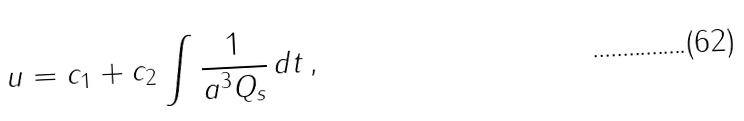<formula> <loc_0><loc_0><loc_500><loc_500>u = c _ { 1 } + c _ { 2 } \int \frac { 1 } { a ^ { 3 } Q _ { s } } \, d t \, ,</formula> 